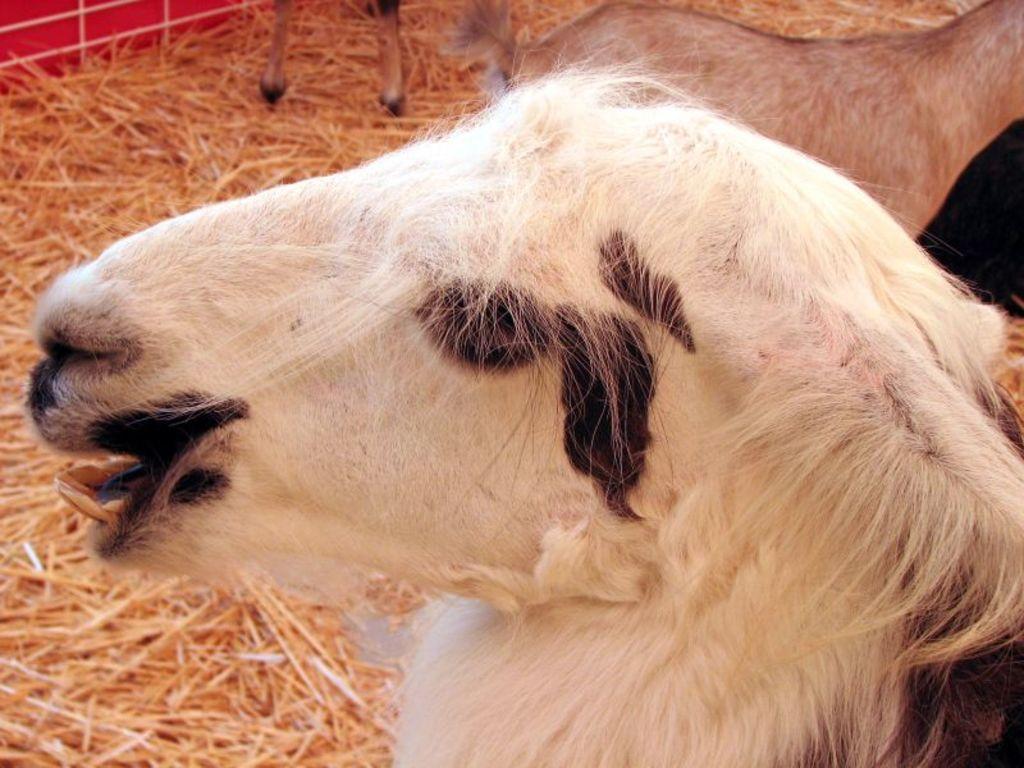Describe this image in one or two sentences. In this image I can see an animal and the animal is in black and white color, background I can the dried grass and the grass is in brown color. 